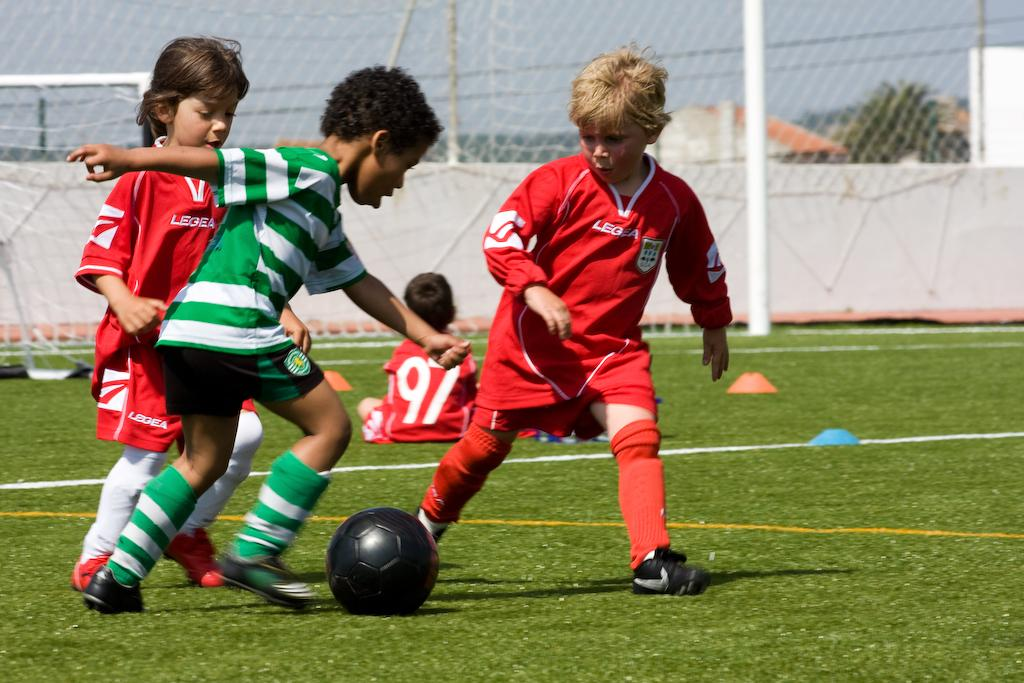What are the kids in the image doing? There are three kids playing football in the image. What is the position of the other kid in the image? There is another kid sitting in the image. What can be seen in the background of the image? There is a net in the background of the image. What type of game is the crowd watching in the image? There is no crowd present in the image, so it is not possible to determine what game they might be watching. 